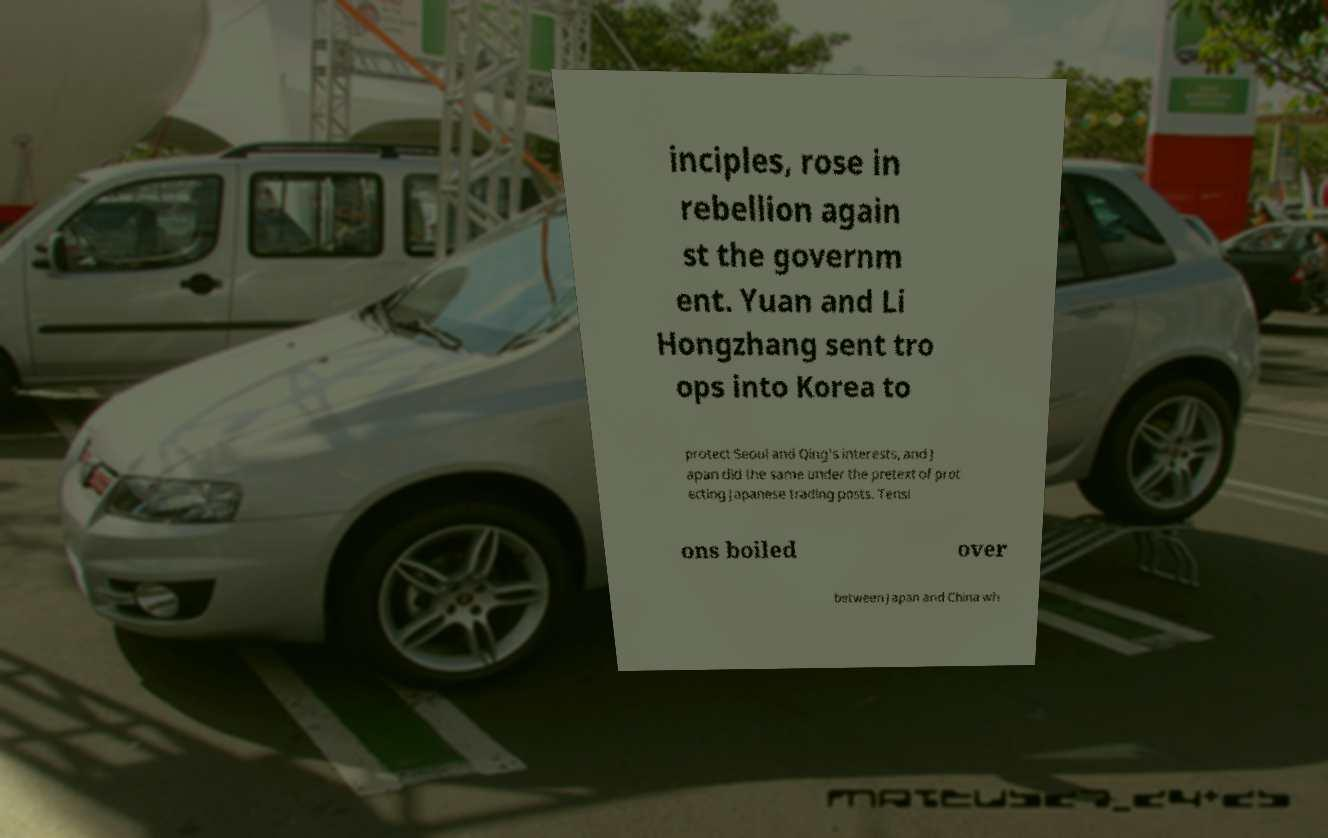There's text embedded in this image that I need extracted. Can you transcribe it verbatim? inciples, rose in rebellion again st the governm ent. Yuan and Li Hongzhang sent tro ops into Korea to protect Seoul and Qing's interests, and J apan did the same under the pretext of prot ecting Japanese trading posts. Tensi ons boiled over between Japan and China wh 